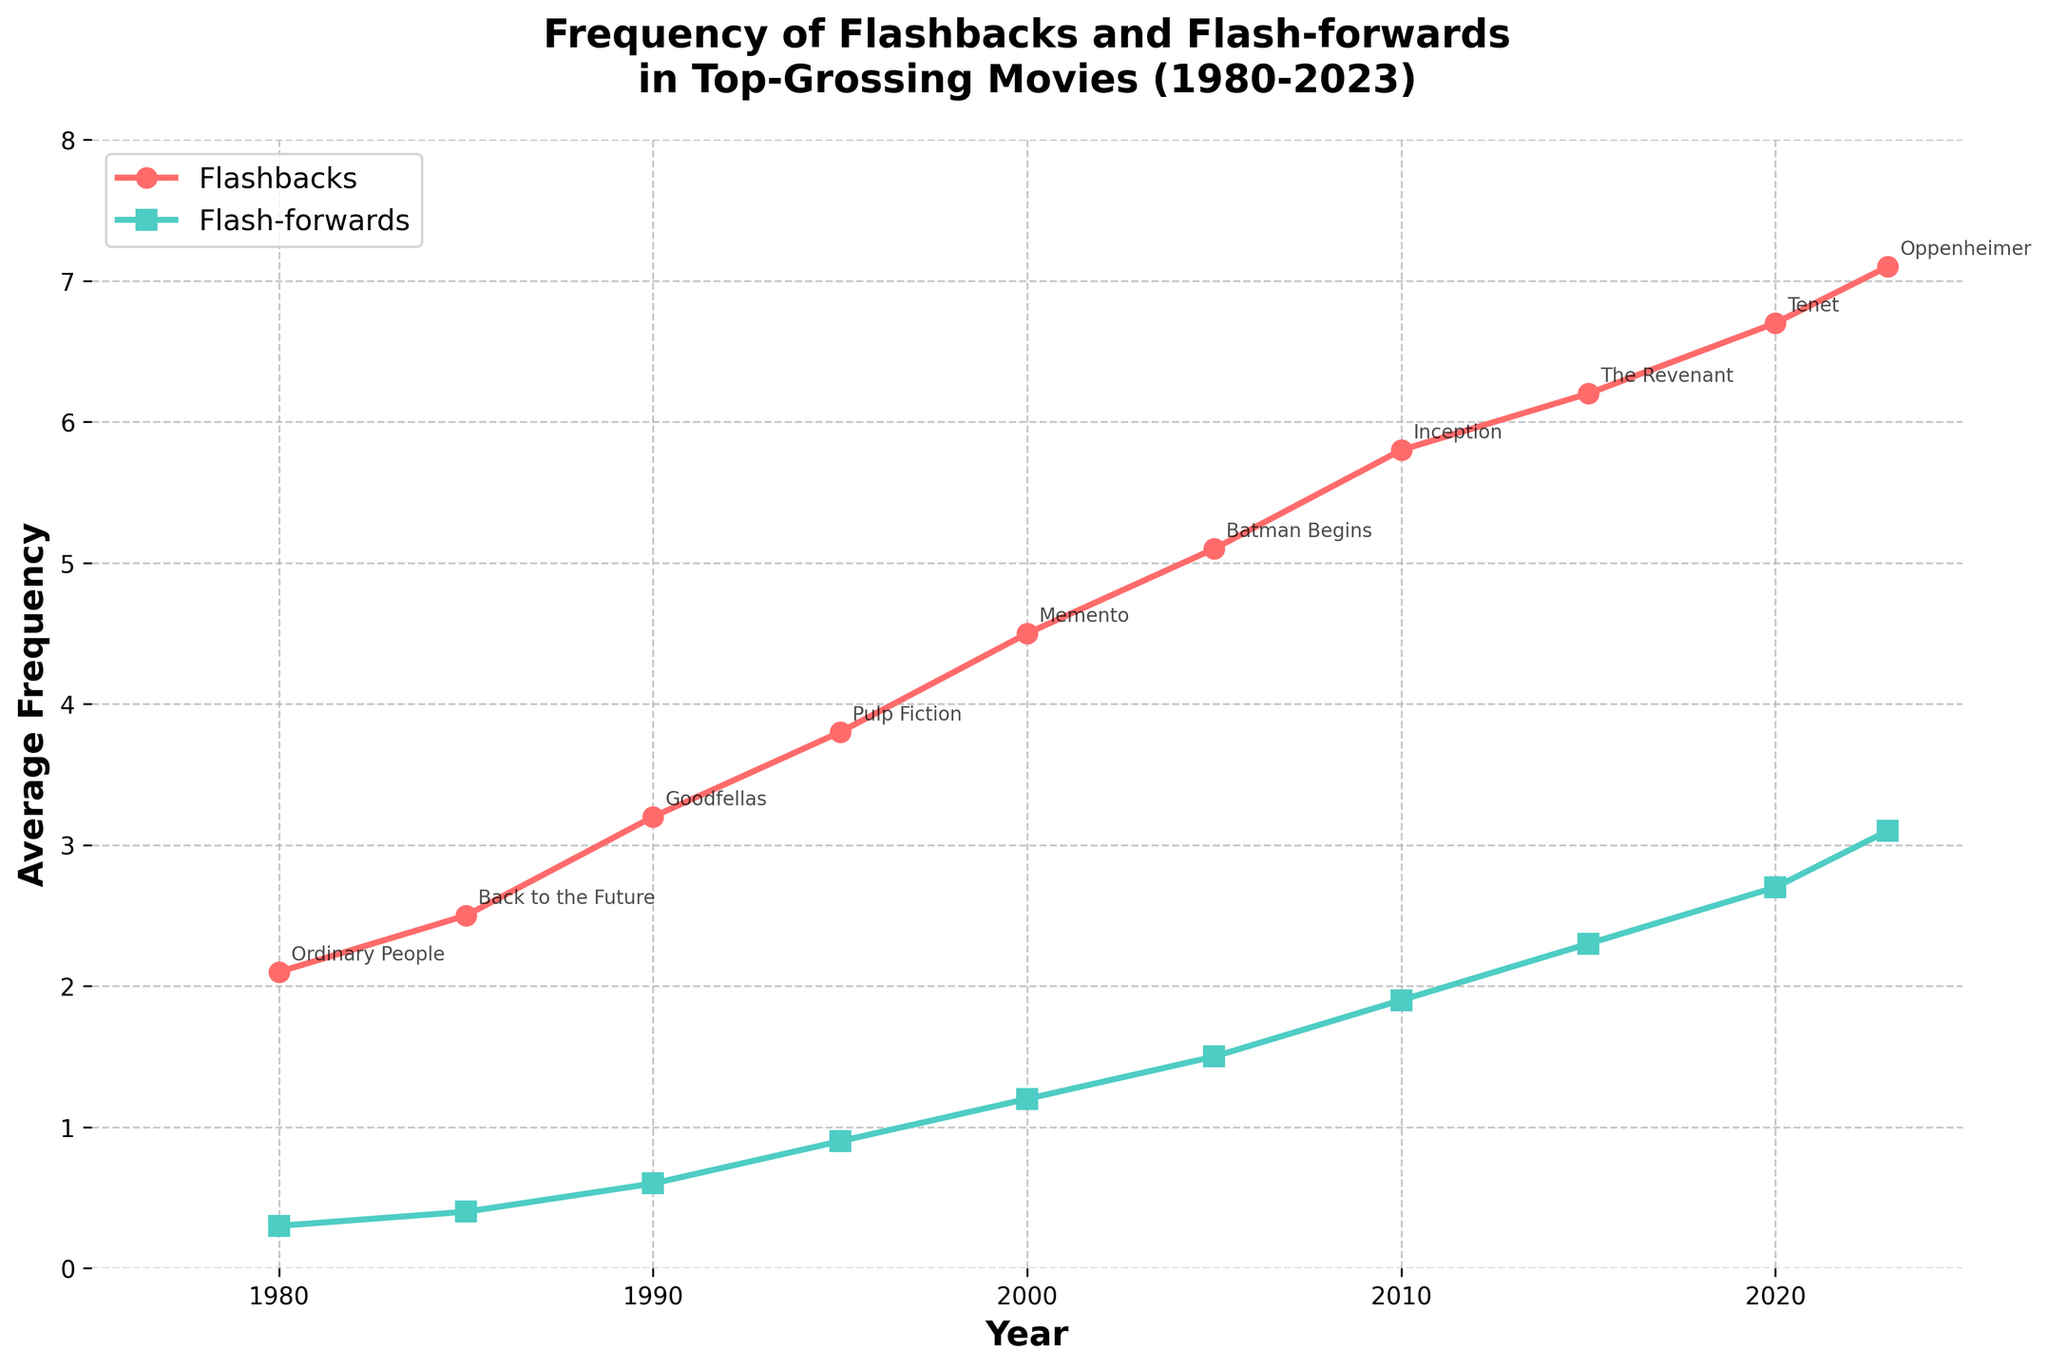what trend do you observe in the frequency of flashbacks from 1980 to 2023? To observe the trend, look at the line representing flashbacks in red. Notice that it starts at 2.1 in 1980 and steadily increases, reaching 7.1 in 2023. This shows a clear upward trend.
Answer: An increasing trend which year had the highest frequency of flash-forwards, and what was the notable example for that year? Look at the green line representing flash-forwards. The highest point is in 2023, where the frequency is 3.1. The notable example for that year is "Oppenheimer."
Answer: 2023, Oppenheimer how much greater was the frequency of flashbacks compared to flash-forwards in 2010? Identify the values at 2010 for both flashbacks and flash-forwards from the plot. Flashbacks were 5.8, and flash-forwards were 1.9. Subtract 1.9 from 5.8: 5.8 - 1.9 = 3.9.
Answer: 3.9 what notable example appears in 2000, and how do the frequencies of flashbacks and flash-forwards for that year compare? For 2000, the plot shows "Memento" as the notable example. Flashbacks were 4.5, while flash-forwards were 1.2. Comparing the two values, flashbacks (4.5) are higher than flash-forwards (1.2).
Answer: Memento, flashbacks are higher calculate the average frequency of flashbacks from 1980 to 2000. Identify the values for flashbacks from 1980 to 2000: [2.1, 2.5, 3.2, 3.8, 4.5]. Sum these values: 2.1 + 2.5 + 3.2 + 3.8 + 4.5 = 16.1. Divide by the number of years (5): 16.1 / 5 = 3.22.
Answer: 3.22 which year's notable example included both a high frequency of flashbacks and a moderate frequency of flash-forwards? Look for a year with both high flashback and moderate flash-forward frequency. In 2015, "The Revenant" had 6.2 flashbacks and 2.3 flash-forwards, meeting both criteria.
Answer: 2015, The Revenant compare the rate of increase in the frequency of flashbacks and flash-forwards from 1990 to 2000. Calculate the increase for both from 1990 to 2000. Flashbacks increased from 3.2 to 4.5 (4.5 - 3.2 = 1.3). Flash-forwards increased from 0.6 to 1.2 (1.2 - 0.6 = 0.6). Compare the two increases: flashbacks (1.3) increased faster than flash-forwards (0.6).
Answer: Flashbacks increased faster identify the general relationship between the frequencies of flashbacks and flash-forwards over the entire period. Observing the overall trend, flashbacks (red line) have consistently been higher than flash-forwards (green line) for all years from 1980 to 2023.
Answer: Flashbacks are higher 